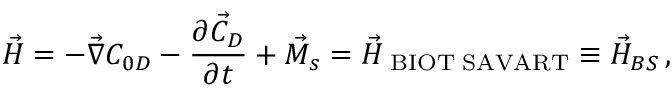<formula> <loc_0><loc_0><loc_500><loc_500>\vec { H } = - \vec { \nabla } C _ { 0 D } - \frac { \partial \vec { C } _ { D } } { \partial t } + \vec { M } _ { s } = \vec { H } _ { B I O T S A V A R T } \equiv \vec { H } _ { B S } \, ,</formula> 